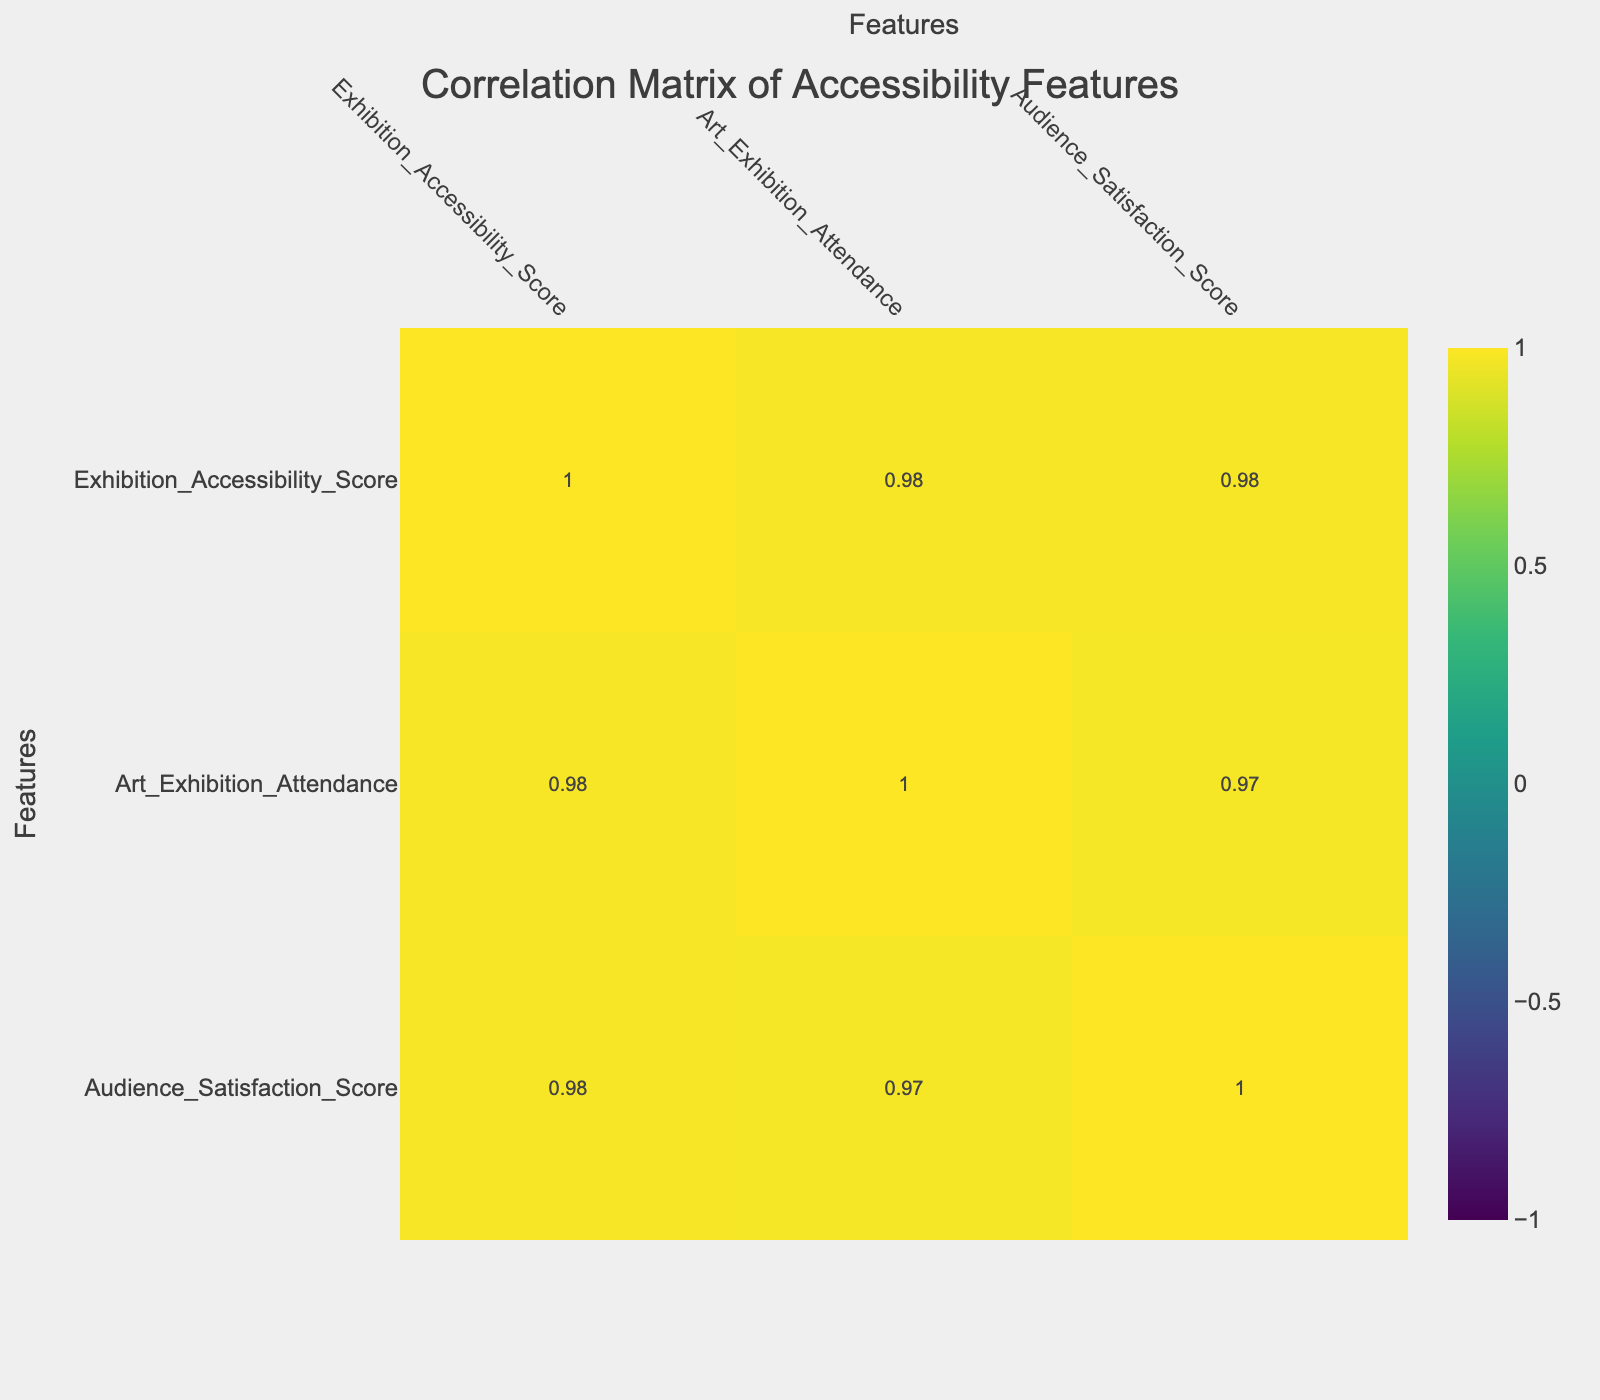What is the correlation between Accessible Seating and Art Exhibition Attendance? From the correlation table, we can directly read the correlation value between Accessible Seating and Art Exhibition Attendance, which is 0.9.
Answer: 0.9 Which accessibility feature has the highest correlation with Audience Satisfaction Score? By looking at the correlations in the Audience Satisfaction Score row, Sign Language Interpreters has the highest correlation value of 0.93 with attendance.
Answer: 0.93 What is the average Art Exhibition Attendance for the features with a score above 7? First, we identify the features with scores above 7: Wheelchair Ramps (2500), Sign Language Interpreters (3000), Accessible Seating (2700), and Transportation Options (3200). Then, we sum these values: 2500 + 3000 + 2700 + 3200 = 11400. There are 4 features, so the average is 11400 / 4 = 2850.
Answer: 2850 Is there a positive correlation between Wheelchair Ramps and Audience Satisfaction Score? We check the correlation value between Wheelchair Ramps and Audience Satisfaction Score, which is 0.89, indicating a positive correlation.
Answer: Yes What is the difference in Art Exhibition Attendance between features with the highest and lowest Exhibition Accessibility Score? The feature with the highest score is Transportation Options (3200), and the lowest is Braille Description (1500). The difference is 3200 - 1500 = 1700.
Answer: 1700 